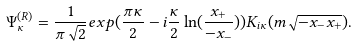<formula> <loc_0><loc_0><loc_500><loc_500>\Psi _ { \kappa } ^ { ( R ) } = \frac { 1 } { \pi \sqrt { 2 } } e x p ( \frac { \pi \kappa } 2 - i \frac { \kappa } 2 \ln ( \frac { x _ { + } } { - x _ { - } } ) ) K _ { i \kappa } ( m \sqrt { - x _ { - } x _ { + } } ) .</formula> 